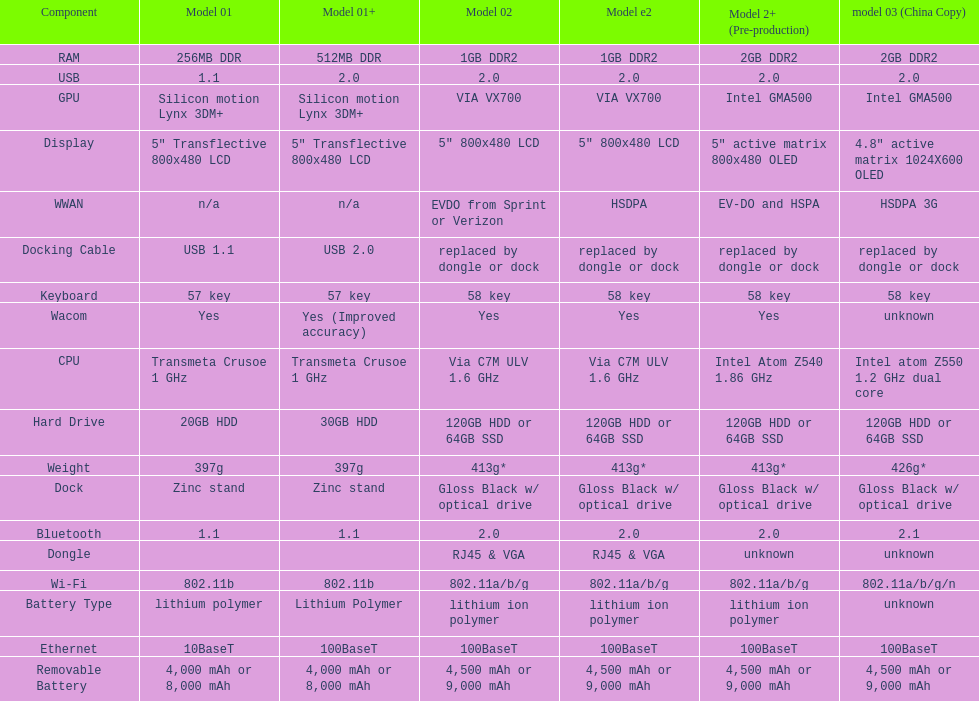What component comes after bluetooth? Wacom. 